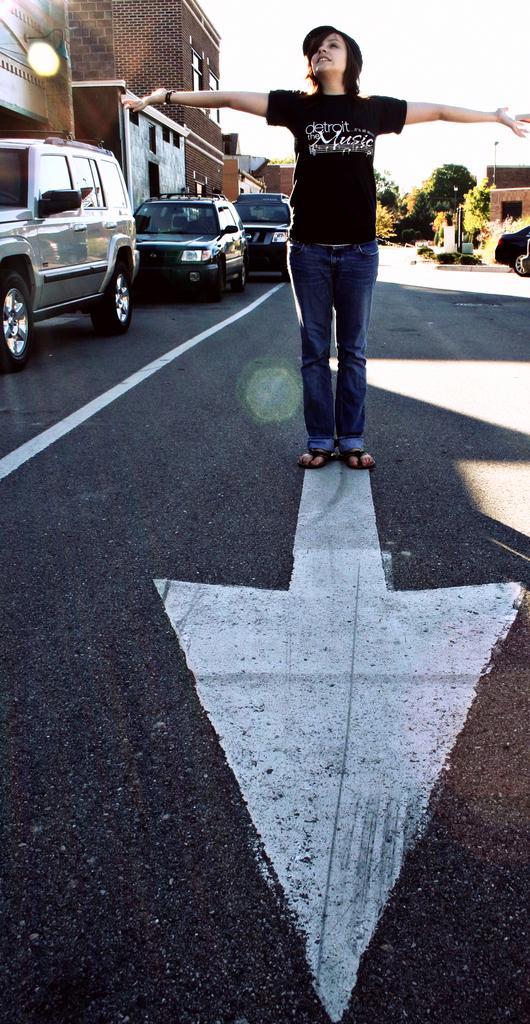How would you summarize this image in a sentence or two? There is a person standing and we can see cars on the road. Background we can see buildings,trees and sky. 